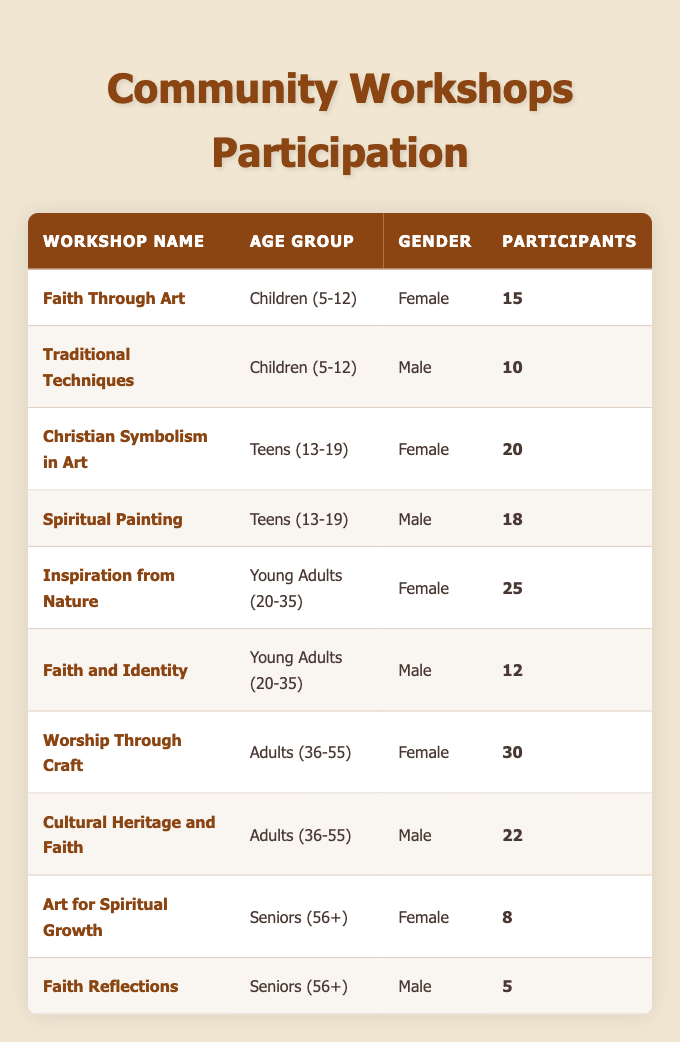What is the name of the workshop with the highest number of female participants? By reviewing the table, it is clear that the "Worship Through Craft" workshop has 30 female participants, which is the highest among the workshops listed for female gender.
Answer: Worship Through Craft How many participants were in the "Faith and Identity" workshop? The table lists the "Faith and Identity" workshop which is for young adults (20-35) and has 12 participants.
Answer: 12 Which age group has the highest total number of participants across all workshops? To determine the age group with the most participants, we need to sum the participants: Children (5-12) = 25, Teens (13-19) = 38, Young Adults (20-35) = 37, Adults (36-55) = 52, Seniors (56+) = 13. Adding these gives us 25 + 38 + 37 + 52 + 13 = 165. The age group with the highest total is Adults (36-55) with 52 participants.
Answer: Adults (36-55) Did more male or female participants attend workshops for young adults? The young adults group (20-35) has 25 female participants in "Inspiration from Nature" and 12 male participants in "Faith and Identity". Therefore, there are more female participants (25) than male participants (12) in this age group.
Answer: More female participants What is the total number of participants in workshops for seniors? The seniors (56+) workshops are "Art for Spiritual Growth" with 8 participants and "Faith Reflections" with 5 participants, totaling 8 + 5 = 13 participants across these workshops.
Answer: 13 Is there a workshop specifically for children that has more participants than the "Traditional Techniques" workshop? "Traditional Techniques" has 10 participants. "Faith Through Art," which is also for children, has 15 participants, which is greater than 10. Thus, there is a workshop specifically for children with more participants.
Answer: Yes What is the difference in participants between the workshop with the most female participants and the one with the most male participants? The "Worship Through Craft" workshop has the most female participants at 30, and "Cultural Heritage and Faith" has the most male participants at 22. The difference is 30 - 22 = 8 participants.
Answer: 8 Are all workshops for children attended by more female participants compared to male participants? "Faith Through Art" has 15 female participants, while "Traditional Techniques" has 10 male participants. Therefore, in the workshops for children, females outnumber males.
Answer: Yes How many total participants are there in the workshops for adults? The workshops for adults (36-55) are "Worship Through Craft" with 30 participants and "Cultural Heritage and Faith" with 22 participants. The total is 30 + 22 = 52 participants in total for adults.
Answer: 52 